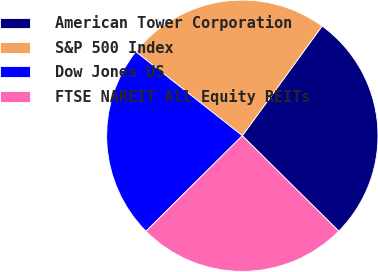<chart> <loc_0><loc_0><loc_500><loc_500><pie_chart><fcel>American Tower Corporation<fcel>S&P 500 Index<fcel>Dow Jones US<fcel>FTSE NAREIT All Equity REITs<nl><fcel>27.41%<fcel>24.38%<fcel>23.06%<fcel>25.15%<nl></chart> 